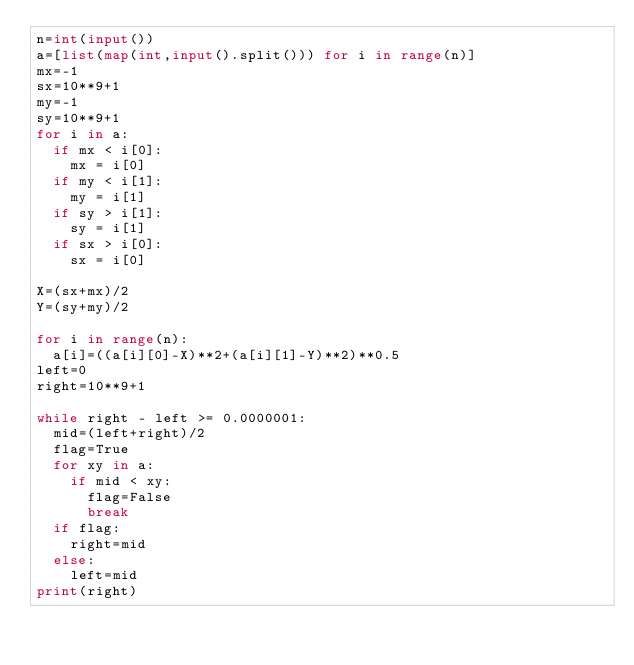Convert code to text. <code><loc_0><loc_0><loc_500><loc_500><_Python_>n=int(input())
a=[list(map(int,input().split())) for i in range(n)]
mx=-1
sx=10**9+1
my=-1
sy=10**9+1
for i in a:
  if mx < i[0]:
    mx = i[0]
  if my < i[1]:
    my = i[1]
  if sy > i[1]:
    sy = i[1]
  if sx > i[0]:
    sx = i[0]

X=(sx+mx)/2
Y=(sy+my)/2

for i in range(n):
  a[i]=((a[i][0]-X)**2+(a[i][1]-Y)**2)**0.5
left=0
right=10**9+1

while right - left >= 0.0000001:
  mid=(left+right)/2
  flag=True
  for xy in a:
    if mid < xy:
      flag=False
      break
  if flag:
    right=mid
  else:
    left=mid
print(right)</code> 